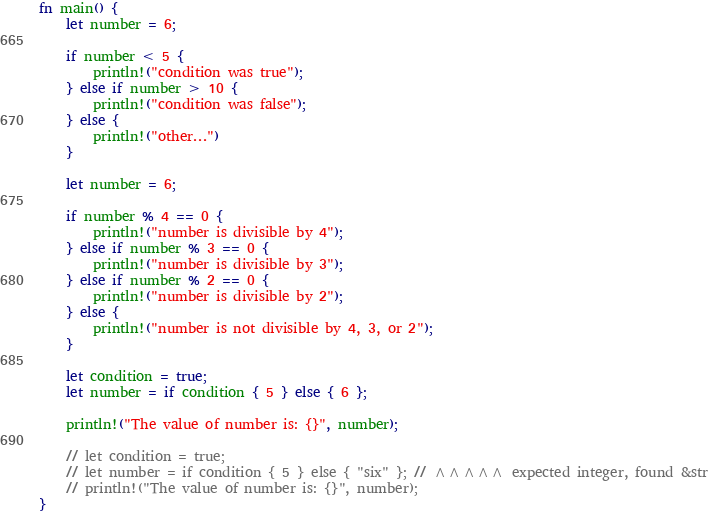Convert code to text. <code><loc_0><loc_0><loc_500><loc_500><_Rust_>fn main() {
    let number = 6;

    if number < 5 {
        println!("condition was true");
    } else if number > 10 {
        println!("condition was false");
    } else {
        println!("other...")
    }

    let number = 6;

    if number % 4 == 0 {
        println!("number is divisible by 4");
    } else if number % 3 == 0 {
        println!("number is divisible by 3");
    } else if number % 2 == 0 {
        println!("number is divisible by 2");
    } else {
        println!("number is not divisible by 4, 3, or 2");
    }

    let condition = true;
    let number = if condition { 5 } else { 6 };

    println!("The value of number is: {}", number);

    // let condition = true;
    // let number = if condition { 5 } else { "six" }; // ^^^^^ expected integer, found &str
    // println!("The value of number is: {}", number);
}
</code> 